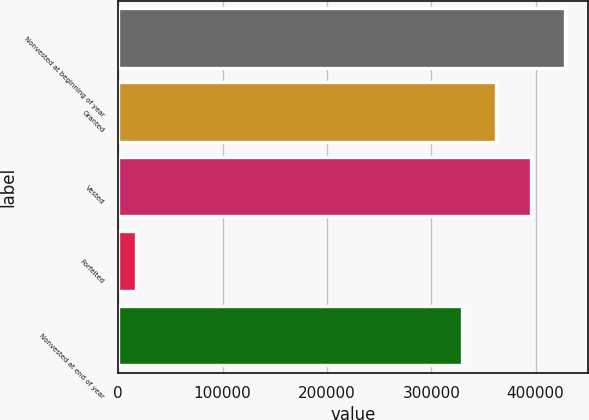<chart> <loc_0><loc_0><loc_500><loc_500><bar_chart><fcel>Nonvested at beginning of year<fcel>Granted<fcel>Vested<fcel>Forfeited<fcel>Nonvested at end of year<nl><fcel>428572<fcel>362275<fcel>395423<fcel>17156<fcel>329126<nl></chart> 